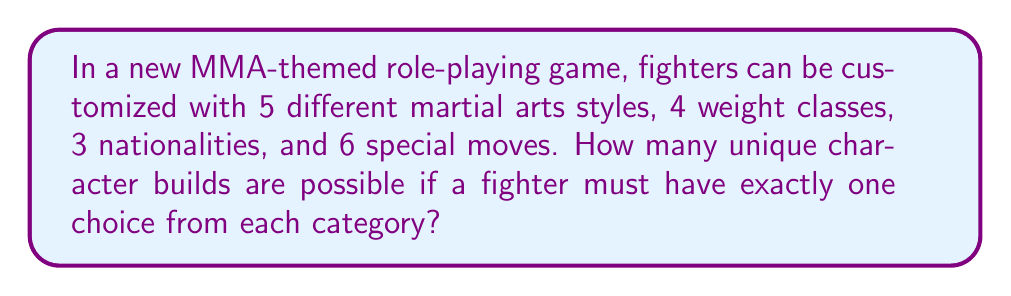Show me your answer to this math problem. To solve this problem, we'll use the multiplication principle of counting. This principle states that if we have several independent choices, the total number of ways to make these choices is the product of the number of ways to make each individual choice.

Let's break down the choices:
1. Martial arts styles: 5 options
2. Weight classes: 4 options
3. Nationalities: 3 options
4. Special moves: 6 options

Since a fighter must have exactly one choice from each category, and the choices are independent of each other, we multiply the number of options for each category:

$$ \text{Total unique builds} = 5 \times 4 \times 3 \times 6 $$

Calculating this:
$$ \text{Total unique builds} = 360 $$

This means that there are 360 different ways to create a unique fighter in this MMA-themed role-playing game.
Answer: 360 